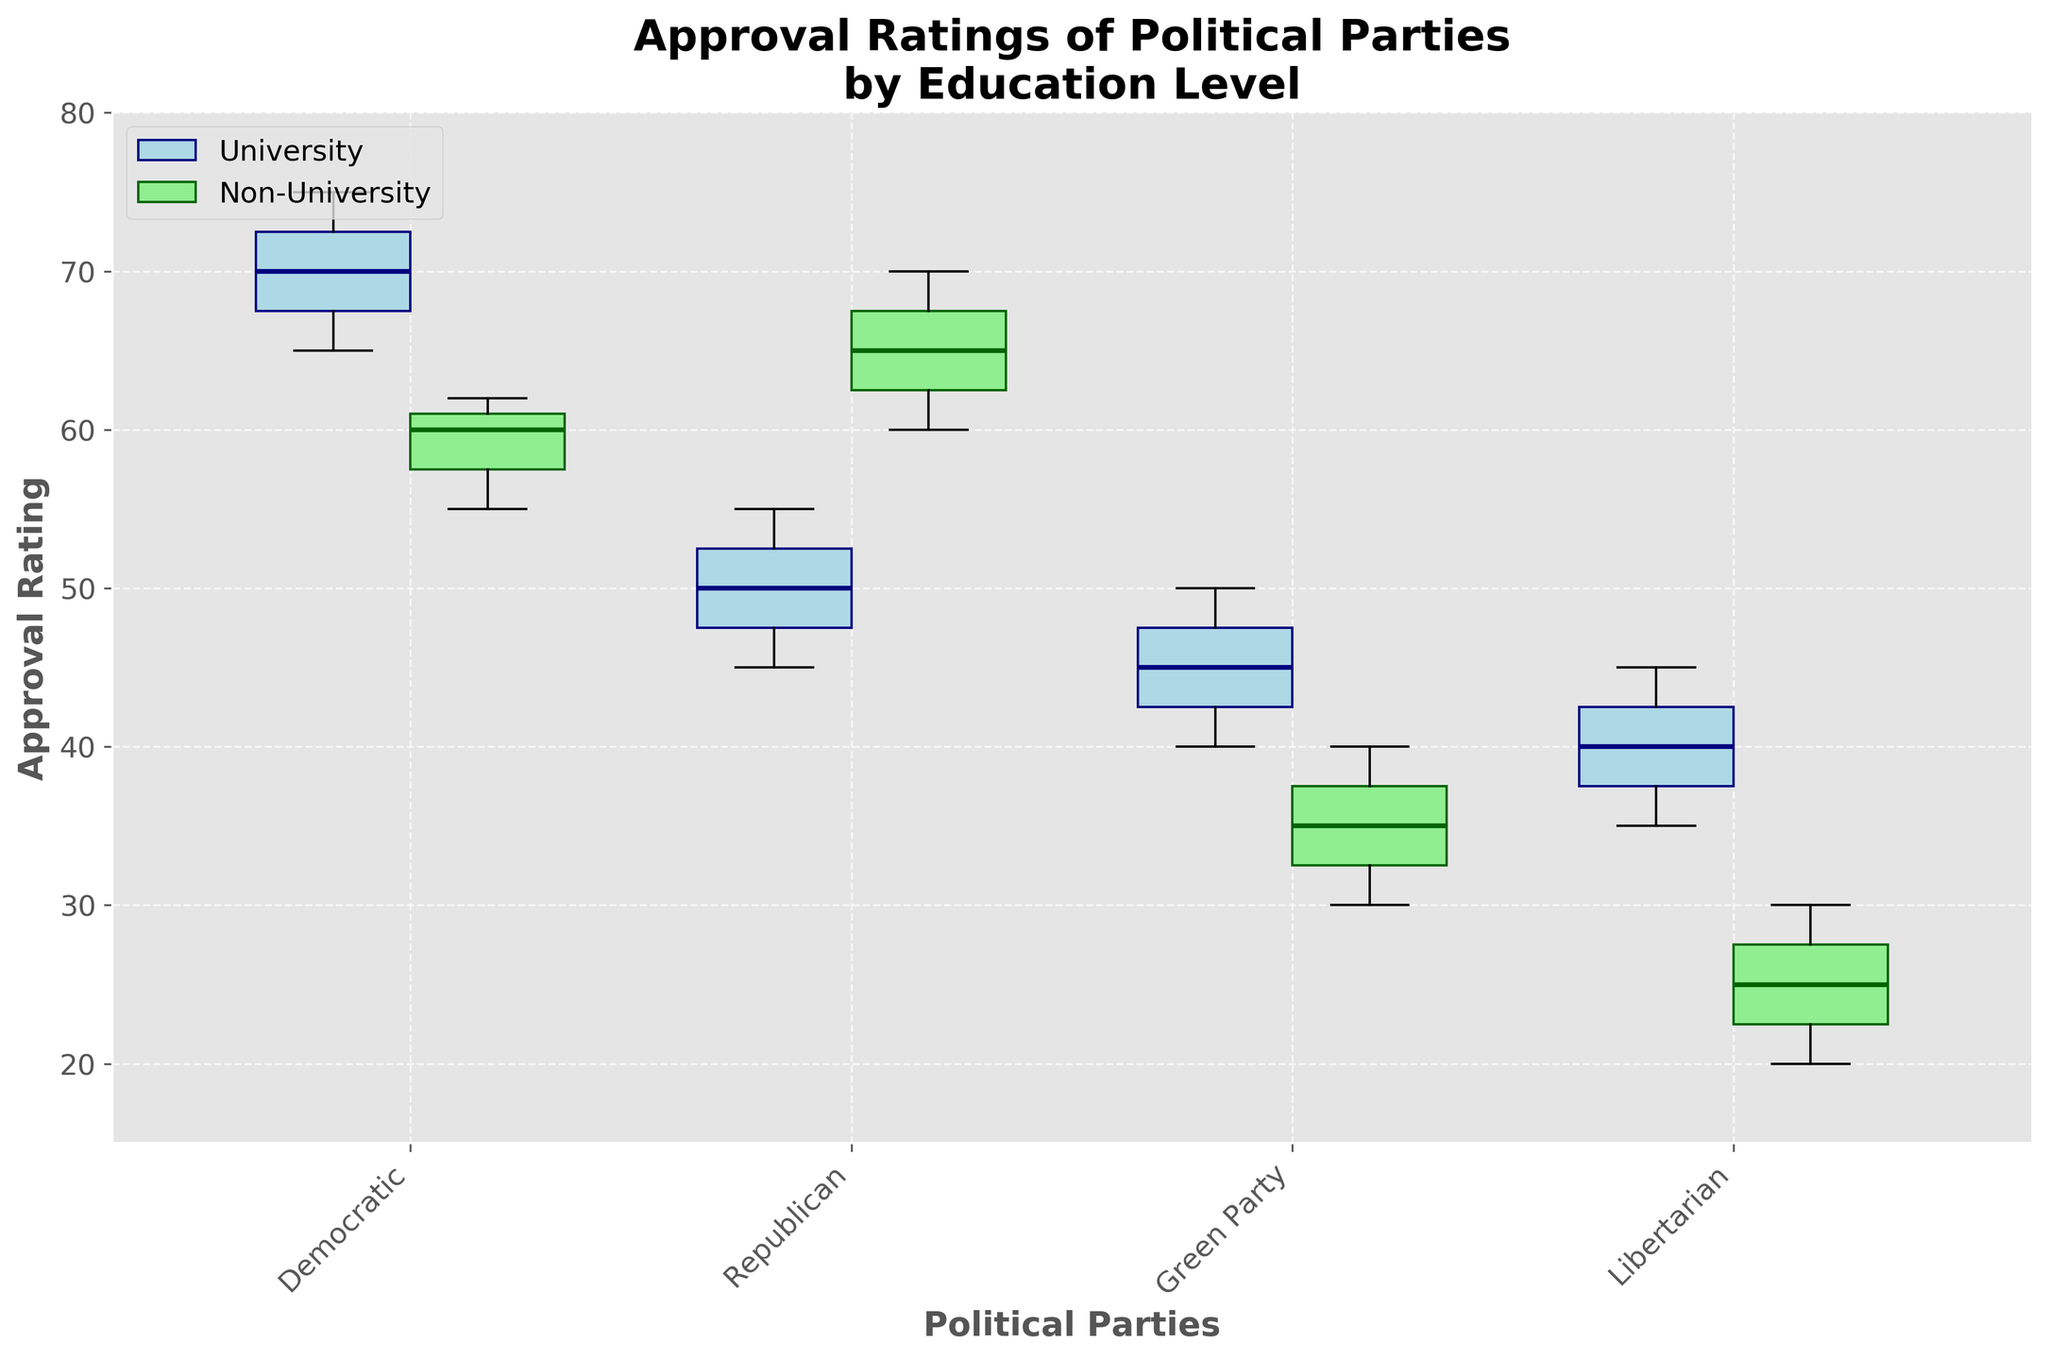What is the title of the figure? The title of the figure can be found at the top of the chart. It provides a description of what the plot is about.
Answer: Approval Ratings of Political Parties by Education Level What are the colors used for the boxes representing university-educated and non-university-educated voters? From the figure, visual inspection will show that the boxes representing university-educated voters are light blue, while those representing non-university-educated voters are light green.
Answer: Light blue and light green What is the median approval rating for the Democratic Party among university-educated voters? The median can be identified by the line inside the box corresponding to university-educated voters for the Democratic Party.
Answer: 70 Between university-educated and non-university-educated voters, which group has the higher median approval rating for the Republican Party? Look at the lines inside the boxes for both educational groups for the Republican Party. Compare the two medians.
Answer: Non-University-educated voters Which political party has the lowest range in approval ratings among non-university-educated voters? The range can be deduced by finding the difference between the maximum and minimum values in the box plot for each party among non-university-educated voters. Identify the smallest range.
Answer: Green Party What is the interquartile range (IQR) for the Green Party among university-educated voters? The IQR is the range between the first quartile (Q1) and the third quartile (Q3). It can be calculated by finding the distance between the bottom and top edges of the box for the Green Party among university-educated voters.
Answer: 10 How does the median approval rating of the Libertarian Party among university-educated voters compare to the median rating among non-university-educated voters? Compare the line (median) inside the box for both educational groups for the Libertarian Party to see which one is higher.
Answer: Higher among university-educated Which group shows more variability in approval ratings for the Republican Party, university-educated voters or non-university-educated voters? Variability is indicated by the length of the box and the whiskers. The box and whiskers for the group showing more variability will be longer.
Answer: Non-University-educated voters What is the median approval rating for the Democratic Party among non-university-educated voters? The median value can be identified by the line inside the box corresponding to non-university-educated voters for the Democratic Party.
Answer: 60 